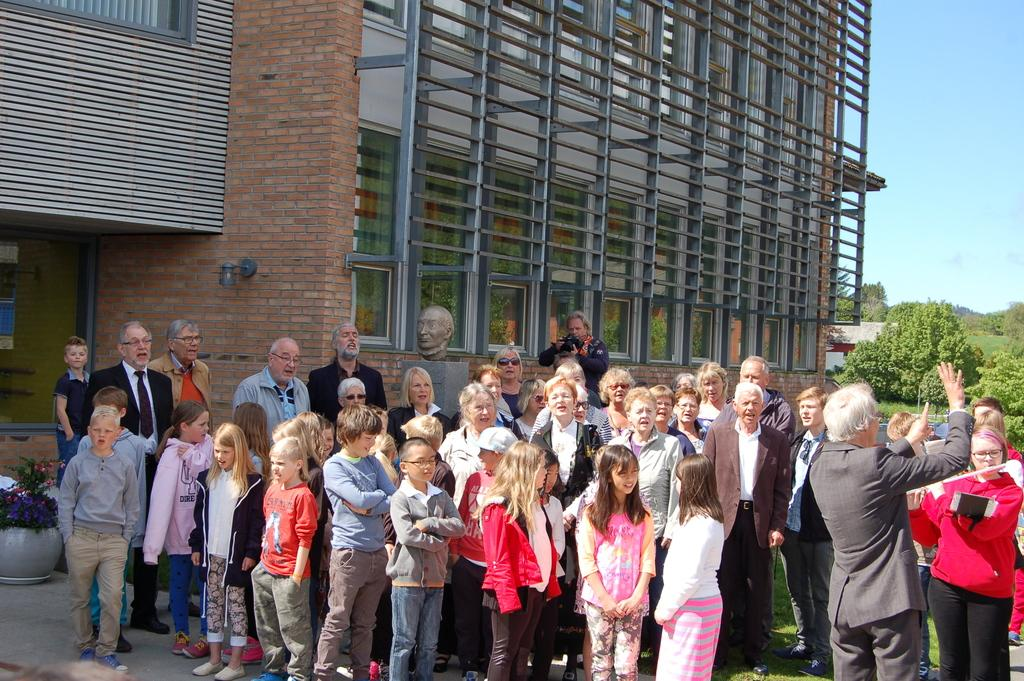What can be seen in the foreground of the image? There is a group of persons standing in the front of the image. What are the expressions of the persons in the image? The persons are smiling. What is visible in the background of the image? There is a building and trees in the background of the image. What type of vegetation is present on the ground in the image? There is grass on the ground in the image. Can you see any thumbs sneezing in the image? There are no thumbs or sneezing depicted in the image. What type of scissors can be seen cutting the grass in the image? There are no scissors present in the image; the grass is not being cut. 